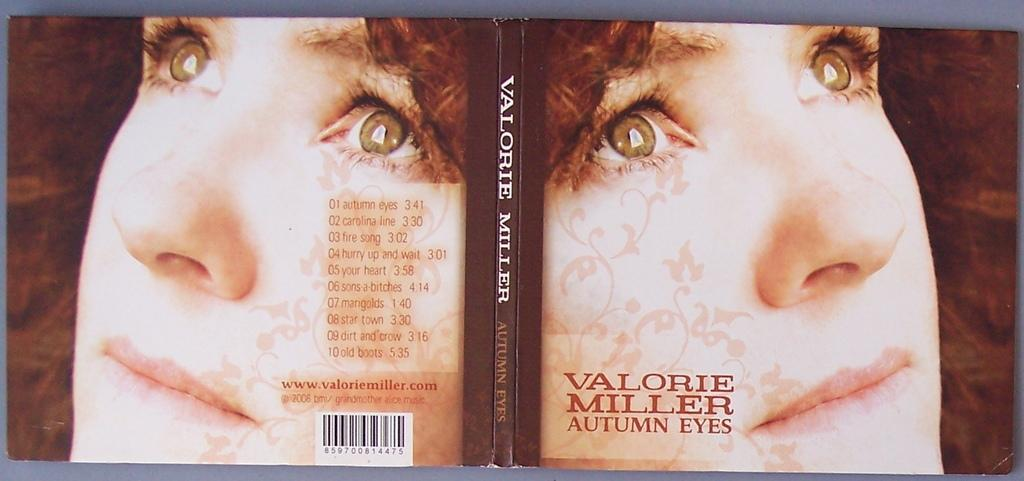What type of object is shown from both the front and back in the image? The image contains the front and back view of a book. Can you describe the person in the image? The person's face is visible in the image. What can be found on the pages of the book? There is text in the image. Is there any additional information about the book in the image? The image contains a bar code. What type of rice can be seen growing in the background of the image? There is no rice visible in the image; it features a book with a person's face and text. Can you tell me how many buildings are depicted in the image? There are no buildings present in the image; it features a book with a person's face and text. 